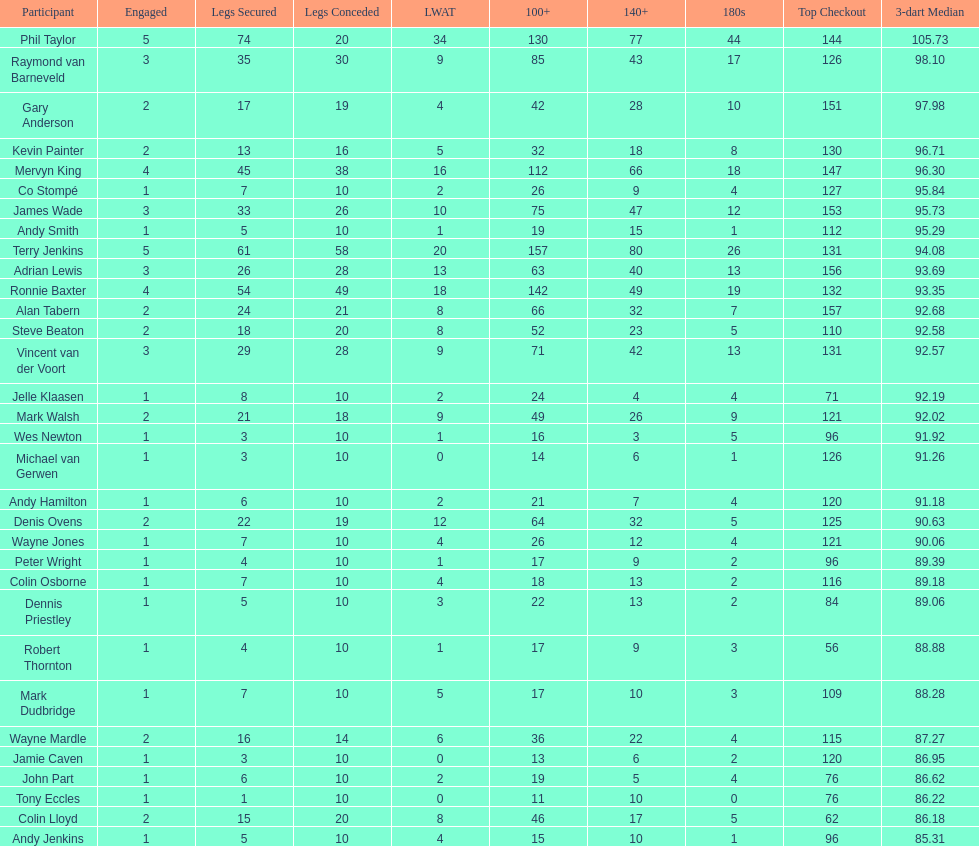Mark walsh's average is above/below 93? Below. 